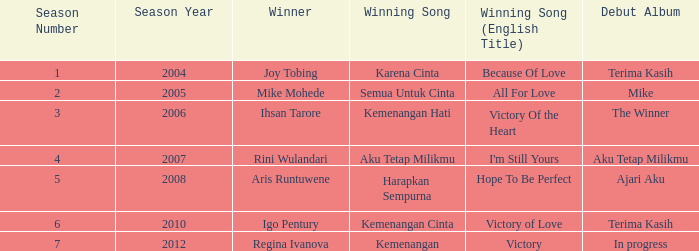Which winning song had a debut album in progress? Kemenangan. 